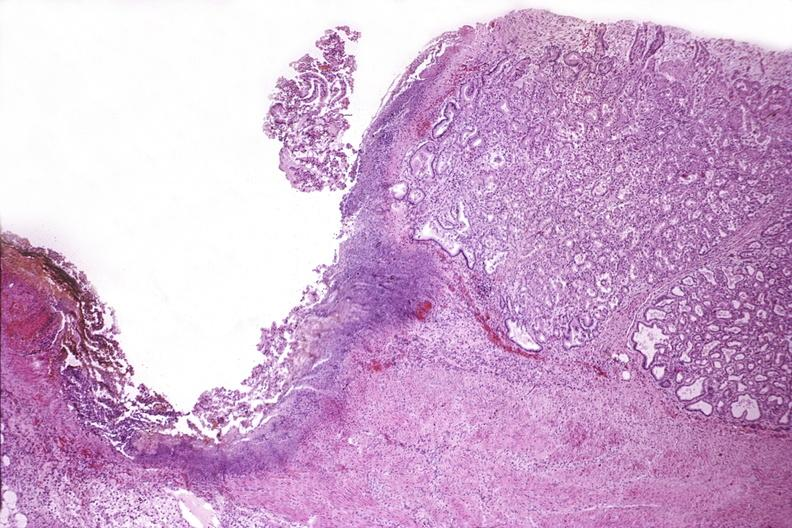does this image show duodenum, chronic pepetic ulcer?
Answer the question using a single word or phrase. Yes 